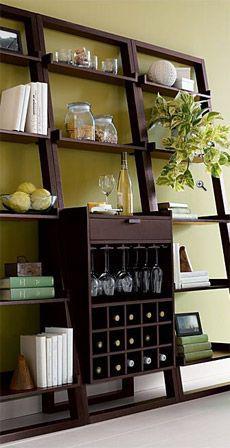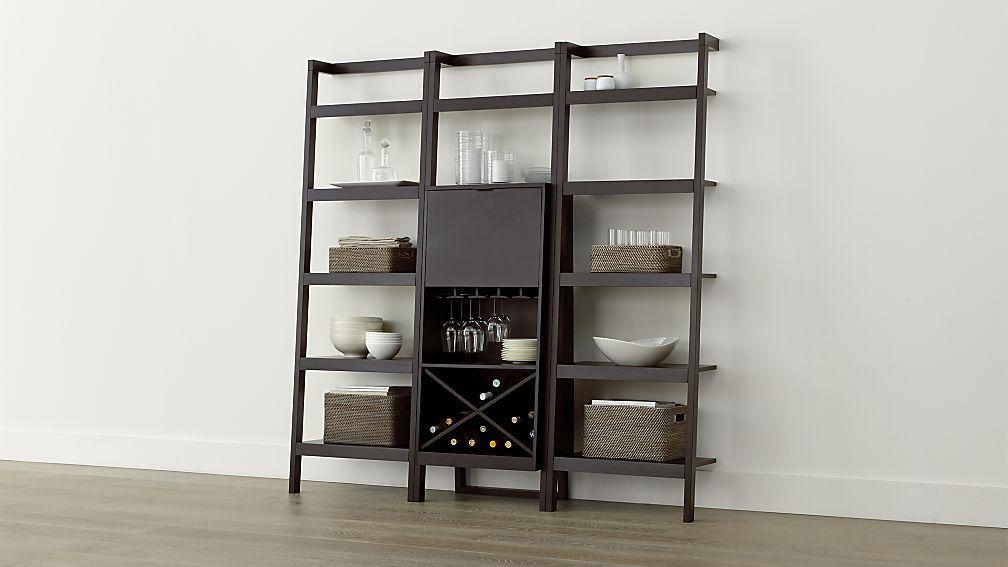The first image is the image on the left, the second image is the image on the right. Assess this claim about the two images: "One storage unit has an X-shaped lower compartment for wine bottles, and the other storage unit has individual bins for bottles in a lower compartment.". Correct or not? Answer yes or no. Yes. The first image is the image on the left, the second image is the image on the right. For the images shown, is this caption "In at least one image there is a brown shelving unit with columns of shelves with the middle bottom set of selve using wood to create an x that can hold wine bottles." true? Answer yes or no. Yes. 